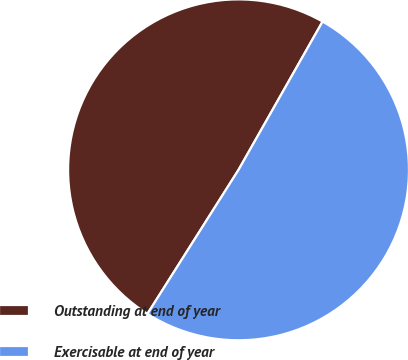<chart> <loc_0><loc_0><loc_500><loc_500><pie_chart><fcel>Outstanding at end of year<fcel>Exercisable at end of year<nl><fcel>49.23%<fcel>50.77%<nl></chart> 